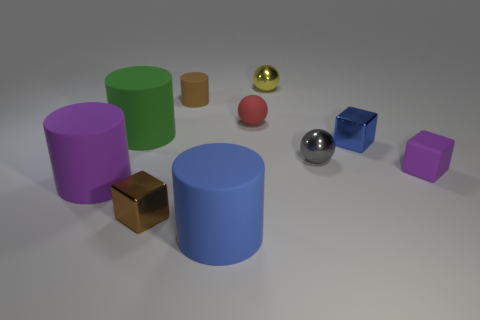What number of tiny things are either green matte cylinders or purple rubber cylinders?
Your answer should be very brief. 0. What is the color of the block that is in front of the purple object left of the big rubber cylinder behind the gray metal ball?
Offer a very short reply. Brown. What number of other things are the same color as the small rubber sphere?
Keep it short and to the point. 0. How many metal objects are either yellow cubes or green cylinders?
Provide a succinct answer. 0. There is a small cube that is behind the tiny purple object; does it have the same color as the shiny ball that is in front of the rubber ball?
Your response must be concise. No. Is there any other thing that has the same material as the brown cube?
Give a very brief answer. Yes. The green rubber thing that is the same shape as the large blue object is what size?
Your response must be concise. Large. Is the number of blue matte cylinders right of the blue cube greater than the number of gray matte cylinders?
Your response must be concise. No. Does the blue object to the right of the blue cylinder have the same material as the small gray sphere?
Provide a succinct answer. Yes. How big is the cube on the left side of the brown object behind the purple object on the right side of the tiny gray metal thing?
Give a very brief answer. Small. 